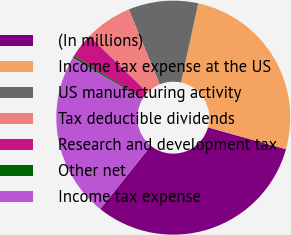Convert chart to OTSL. <chart><loc_0><loc_0><loc_500><loc_500><pie_chart><fcel>(In millions)<fcel>Income tax expense at the US<fcel>US manufacturing activity<fcel>Tax deductible dividends<fcel>Research and development tax<fcel>Other net<fcel>Income tax expense<nl><fcel>31.4%<fcel>25.93%<fcel>9.63%<fcel>6.52%<fcel>3.41%<fcel>0.3%<fcel>22.82%<nl></chart> 